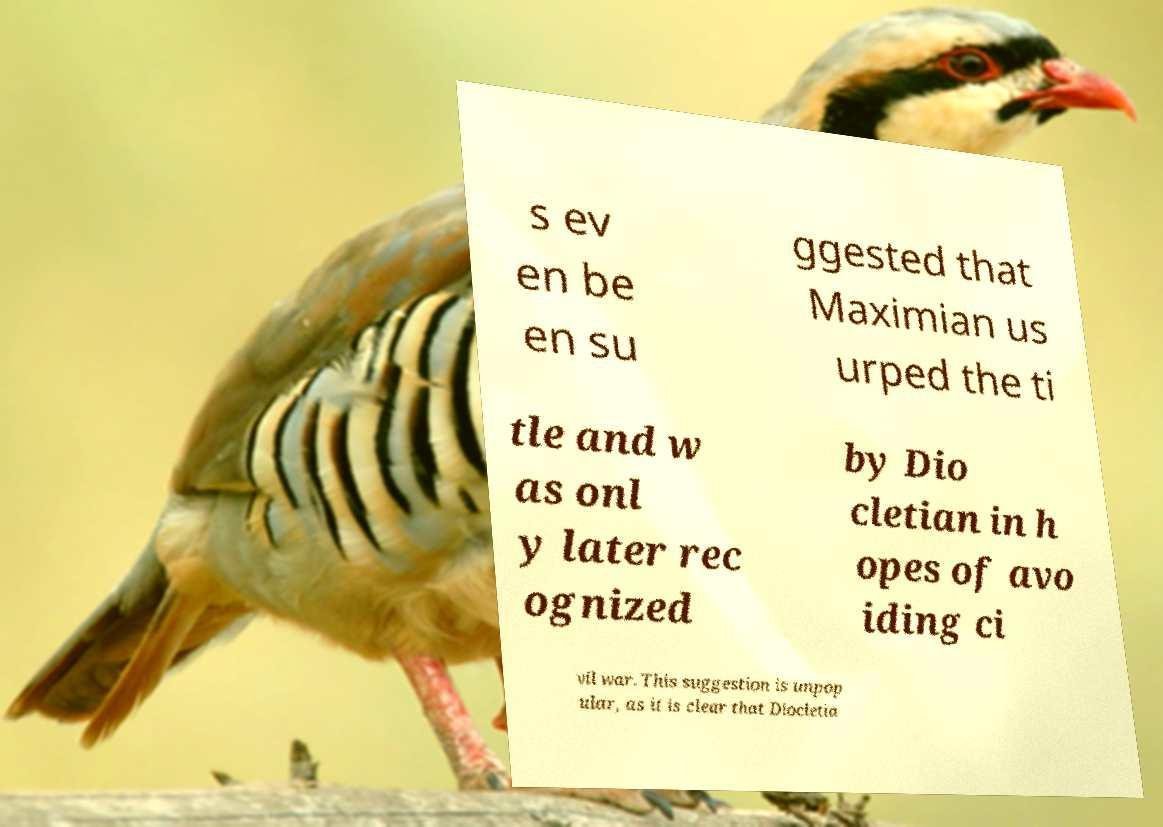Can you accurately transcribe the text from the provided image for me? s ev en be en su ggested that Maximian us urped the ti tle and w as onl y later rec ognized by Dio cletian in h opes of avo iding ci vil war. This suggestion is unpop ular, as it is clear that Diocletia 